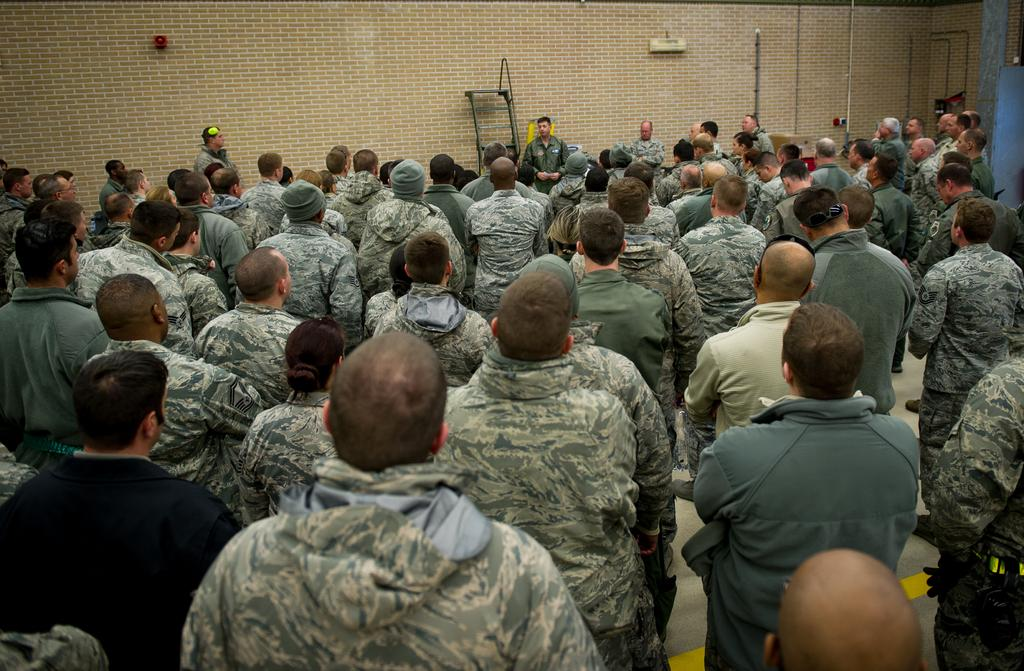How many people are present in the room in the image? There are many men standing in the room. What can be seen on the walls in the background? There is a cream-colored wall in the background. What type of fruit is hanging from the wire in the image? There is no wire or fruit present in the image. In which bedroom are the men standing in the image? The image does not specify a bedroom; it only shows a room with men standing in it. 